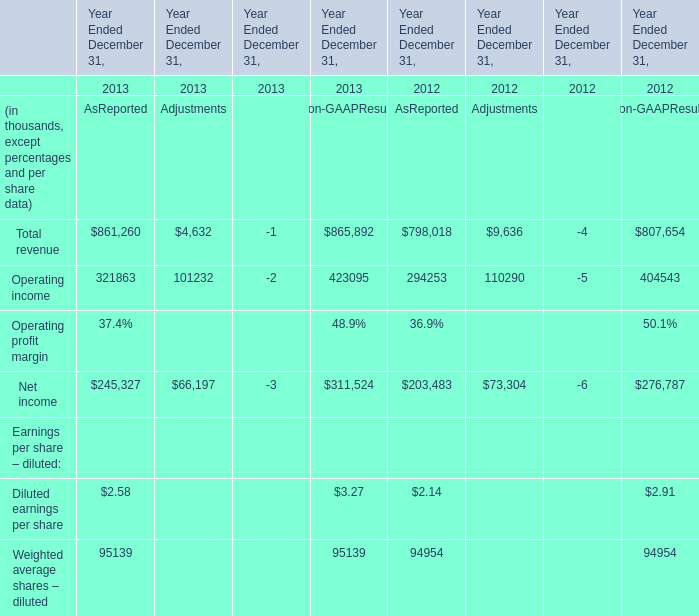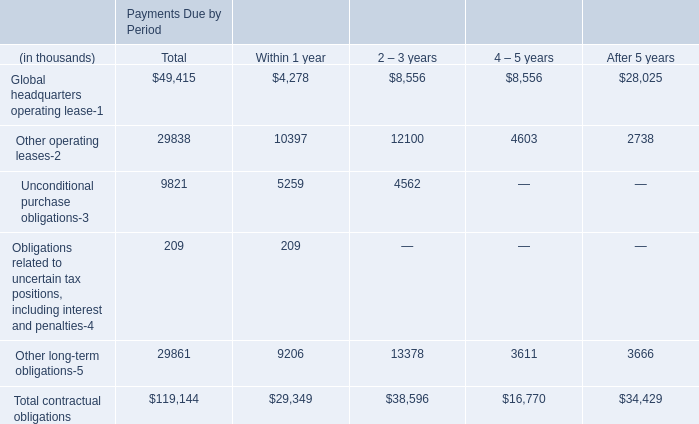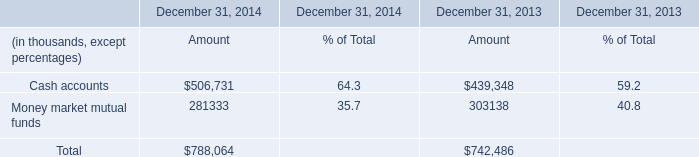In the year with the most Money market mutual funds, what is the growth rate of Net income for AsReported? 
Computations: ((245327 - 203483) / 203483)
Answer: 0.20564. 